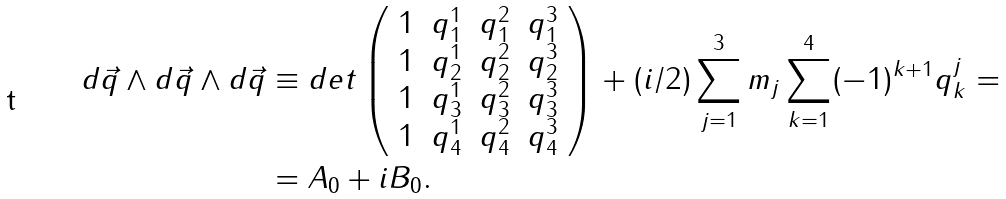Convert formula to latex. <formula><loc_0><loc_0><loc_500><loc_500>d \vec { q } \wedge d \vec { q } \wedge d \vec { q } & \equiv d e t \left ( \begin{array} { c c c c } 1 & q _ { 1 } ^ { 1 } & q _ { 1 } ^ { 2 } & q _ { 1 } ^ { 3 } \\ 1 & q _ { 2 } ^ { 1 } & q _ { 2 } ^ { 2 } & q _ { 2 } ^ { 3 } \\ 1 & q _ { 3 } ^ { 1 } & q _ { 3 } ^ { 2 } & q _ { 3 } ^ { 3 } \\ 1 & q _ { 4 } ^ { 1 } & q _ { 4 } ^ { 2 } & q _ { 4 } ^ { 3 } \\ \end{array} \right ) + ( i / 2 ) \sum _ { j = 1 } ^ { 3 } m _ { j } \sum _ { k = 1 } ^ { 4 } ( - 1 ) ^ { k + 1 } q _ { k } ^ { j } = \\ & = A _ { 0 } + i B _ { 0 } .</formula> 